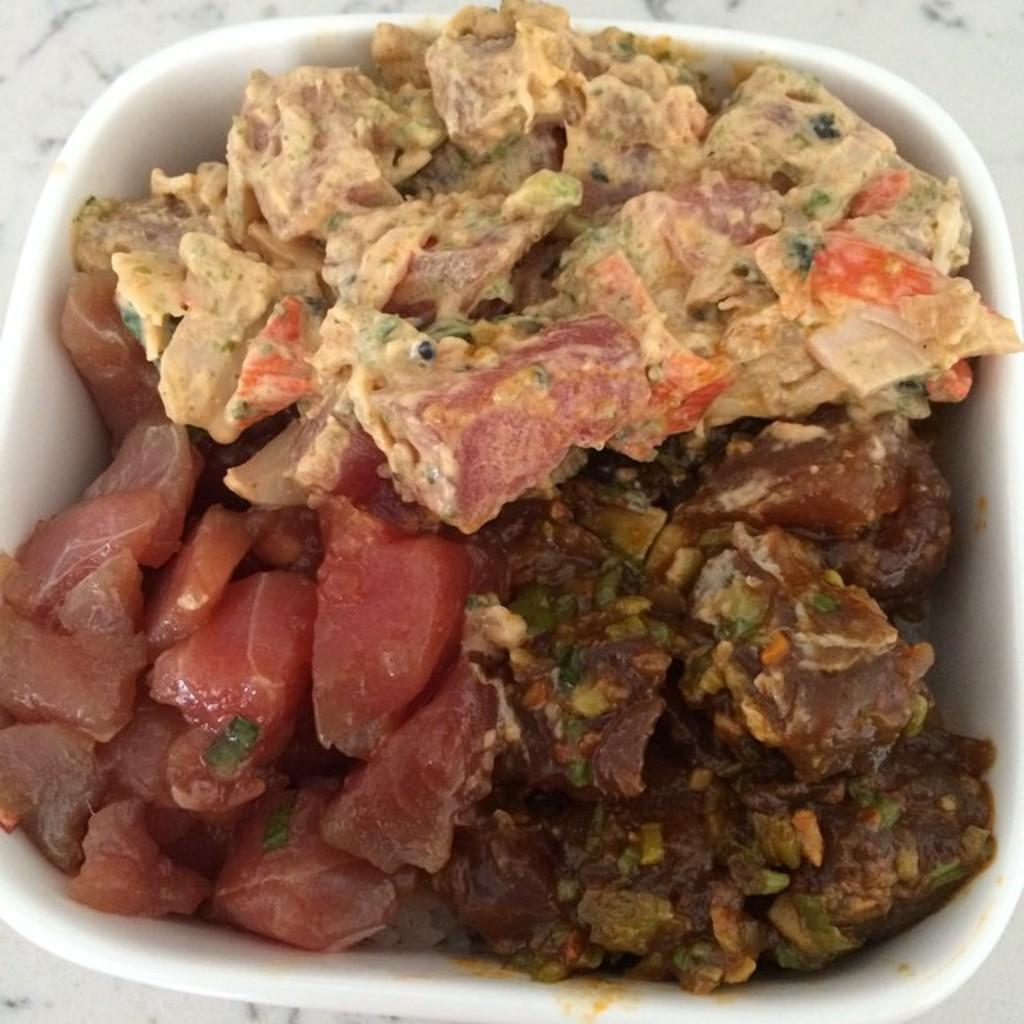What is in the bowl that is visible in the image? There is a bowl in the image. What is inside the bowl? The bowl contains different types of meat. What type of wax can be seen melting in the image? There is no wax present in the image; it features a bowl containing different types of meat. 